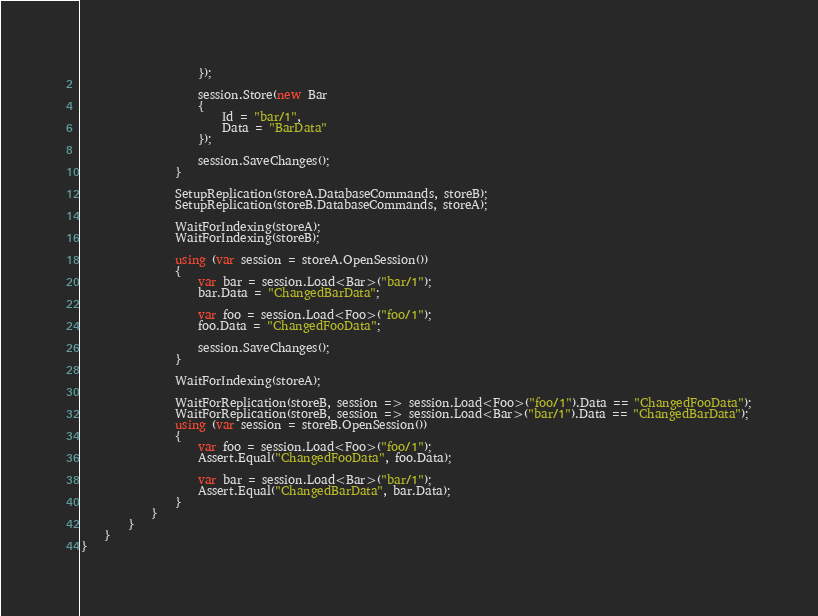Convert code to text. <code><loc_0><loc_0><loc_500><loc_500><_C#_>                    });

                    session.Store(new Bar
                    {
                        Id = "bar/1",
                        Data = "BarData"
                    });

                    session.SaveChanges();
                }

                SetupReplication(storeA.DatabaseCommands, storeB);
                SetupReplication(storeB.DatabaseCommands, storeA);

                WaitForIndexing(storeA);
                WaitForIndexing(storeB);

                using (var session = storeA.OpenSession())
                {
                    var bar = session.Load<Bar>("bar/1");
                    bar.Data = "ChangedBarData";

                    var foo = session.Load<Foo>("foo/1");
                    foo.Data = "ChangedFooData";

                    session.SaveChanges();
                }

                WaitForIndexing(storeA);

                WaitForReplication(storeB, session => session.Load<Foo>("foo/1").Data == "ChangedFooData");
                WaitForReplication(storeB, session => session.Load<Bar>("bar/1").Data == "ChangedBarData");
                using (var session = storeB.OpenSession())
                {
                    var foo = session.Load<Foo>("foo/1");
                    Assert.Equal("ChangedFooData", foo.Data);

                    var bar = session.Load<Bar>("bar/1");
                    Assert.Equal("ChangedBarData", bar.Data);
                }
            }
        }
    }
}
</code> 